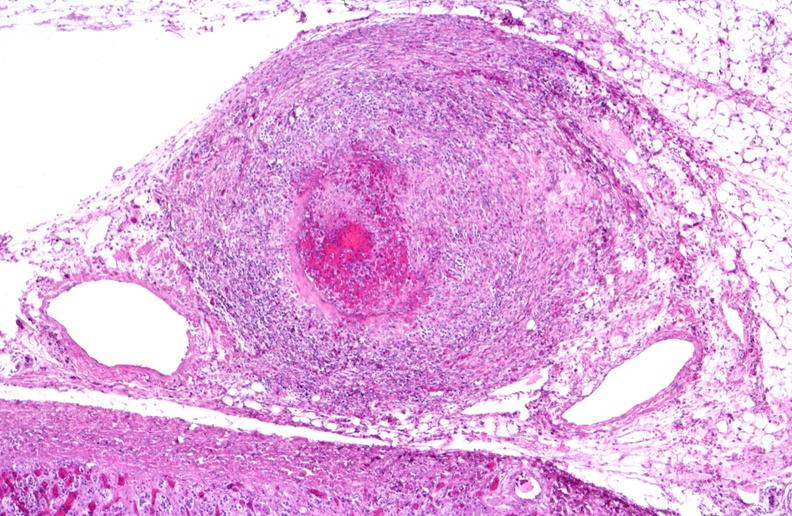what is present?
Answer the question using a single word or phrase. Cardiovascular 